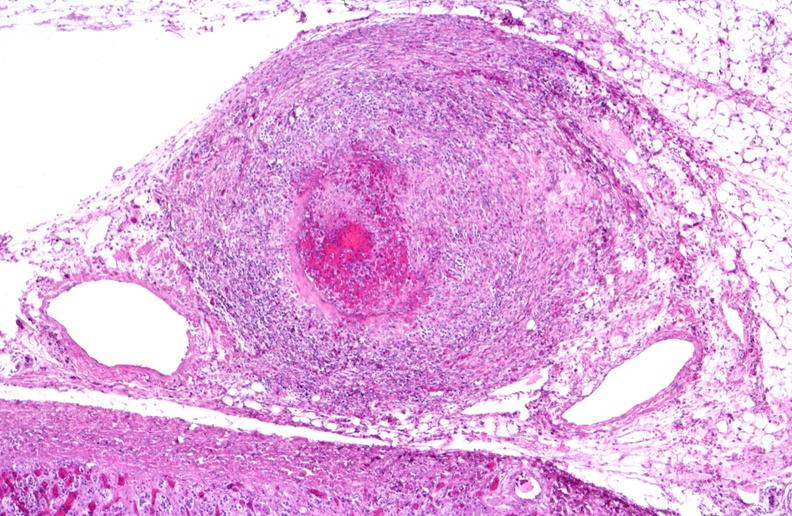what is present?
Answer the question using a single word or phrase. Cardiovascular 